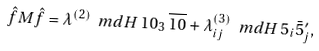<formula> <loc_0><loc_0><loc_500><loc_500>\hat { f } M \hat { f } = \lambda ^ { ( 2 ) } \ m d { H } \, 1 0 _ { 3 } \, \overline { 1 0 } + \lambda ^ { ( 3 ) } _ { i j } \ m d { H } \, 5 _ { i } \bar { 5 } ^ { \prime } _ { j } ,</formula> 